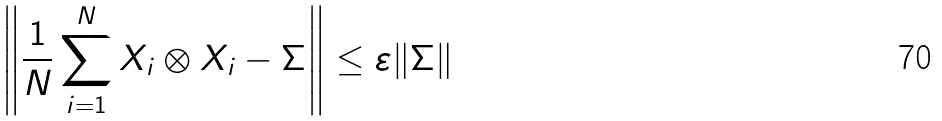<formula> <loc_0><loc_0><loc_500><loc_500>\left \| \frac { 1 } { N } \sum _ { i = 1 } ^ { N } X _ { i } \otimes X _ { i } - \Sigma \right \| \leq \varepsilon \| \Sigma \|</formula> 